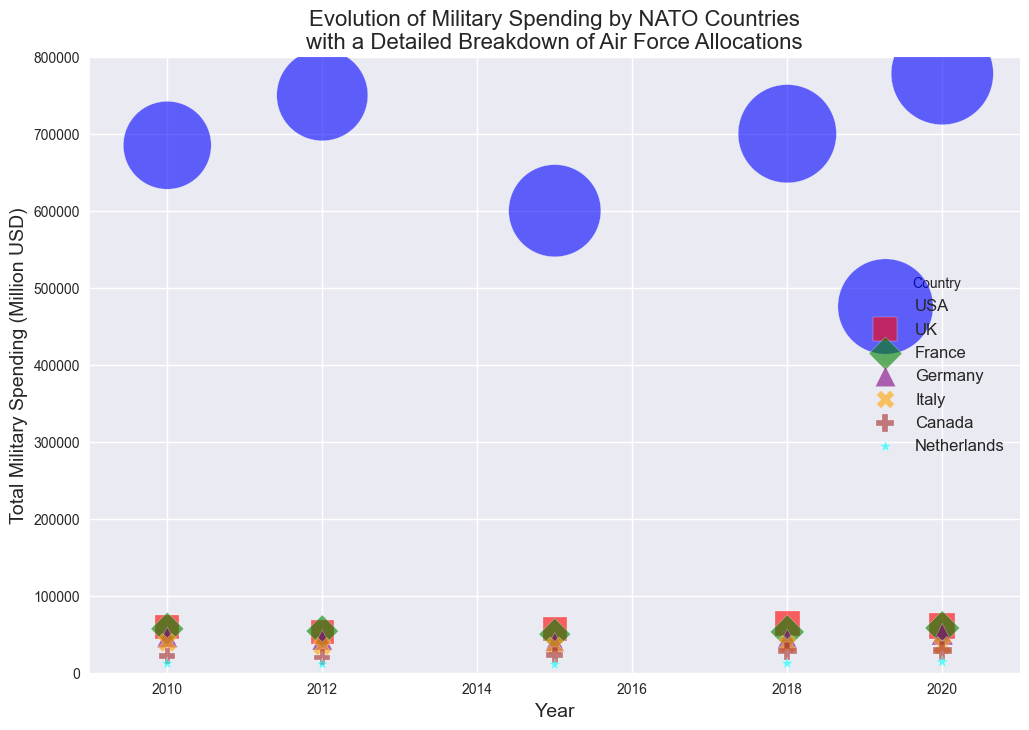Which country has the highest total military spending in 2020? The figure shows the total military spending for each NATO country in 2020. By comparing the heights of the bubbles in 2020, the bubble for the USA stands out as the tallest one.
Answer: USA What is the total military spending for Germany and France combined in 2018? First, locate the bubbles for Germany and France in 2018 and note their military spending values. For Germany, it's 44,000 million USD, and for France, it's 53,000 million USD. Add these values together: 44,000 + 53,000 = 97,000 million USD
Answer: 97,000 million USD Which country has the smallest bubble size in 2010, indicating the lowest air force budget? Check the bubbles in 2010 and compare their sizes. The Netherlands has the smallest bubble, suggesting the lowest air force budget.
Answer: Netherlands How did the UK's total military spending change from 2010 to 2020? Compare the bubble heights for the UK in 2010 and 2020. In 2010, the UK's spending is 59,000 million USD, and in 2020, it's 61,000 million USD. The difference is 61,000 - 59,000 = 2,000 million USD.
Answer: Increased by 2,000 million USD Which country had a decrease in total military spending in 2015 compared to 2012? Examine the bubble heights for each country between 2012 and 2015. The USA, UK, France, Germany, and Italy all show a decrease in 2015 compared to 2012.
Answer: USA, UK, France, Germany, Italy What is the overall trend in air force budgets for NATO countries from 2010 to 2020? Observe the bubble sizes from 2010 to 2020 for all countries. Most countries' bubble sizes either increase or remain constant over the years, indicating an overall increase in air force budgets.
Answer: Increasing trend Which country has a bubble with the largest size for the air force budget in 2018? Check the bubble sizes for each country in 2018. The United States has the largest bubble, indicating the highest air force budget in that year.
Answer: USA Between which years did Canada see the largest increase in total military spending? Compare the bubble heights for Canada across the years. The largest increase is between 2015 (23,000 million USD) and 2018 (28,000 million USD), showing a difference of 5,000 million USD.
Answer: Between 2015 and 2018 Which country has consistently lower total military spending compared to others? Compare the bubble heights of all countries across the years. The Netherlands has consistently lower total military spending than other countries.
Answer: Netherlands 